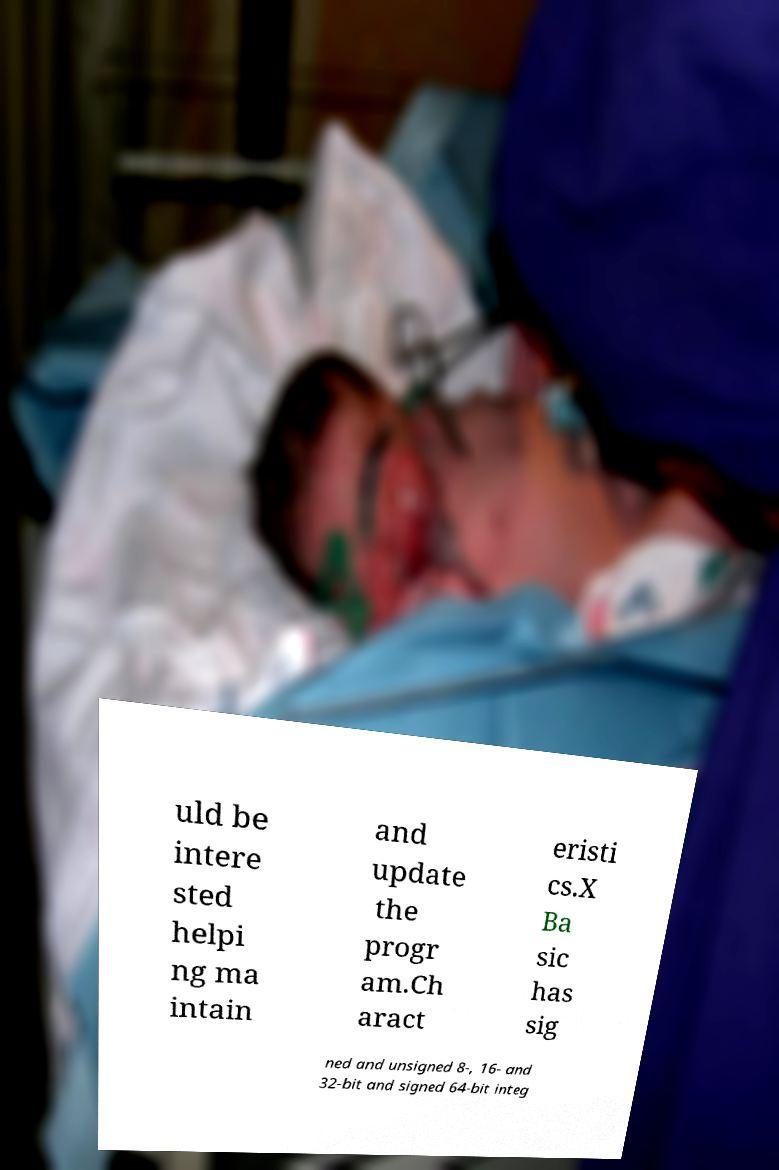There's text embedded in this image that I need extracted. Can you transcribe it verbatim? uld be intere sted helpi ng ma intain and update the progr am.Ch aract eristi cs.X Ba sic has sig ned and unsigned 8-, 16- and 32-bit and signed 64-bit integ 